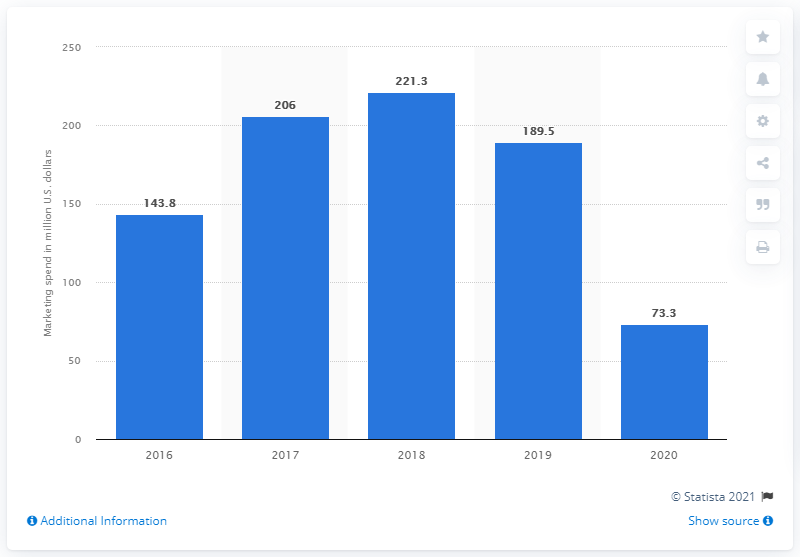Highlight a few significant elements in this photo. Samsonite spent approximately 73.3 million U.S. dollars on marketing efforts in 2020. 